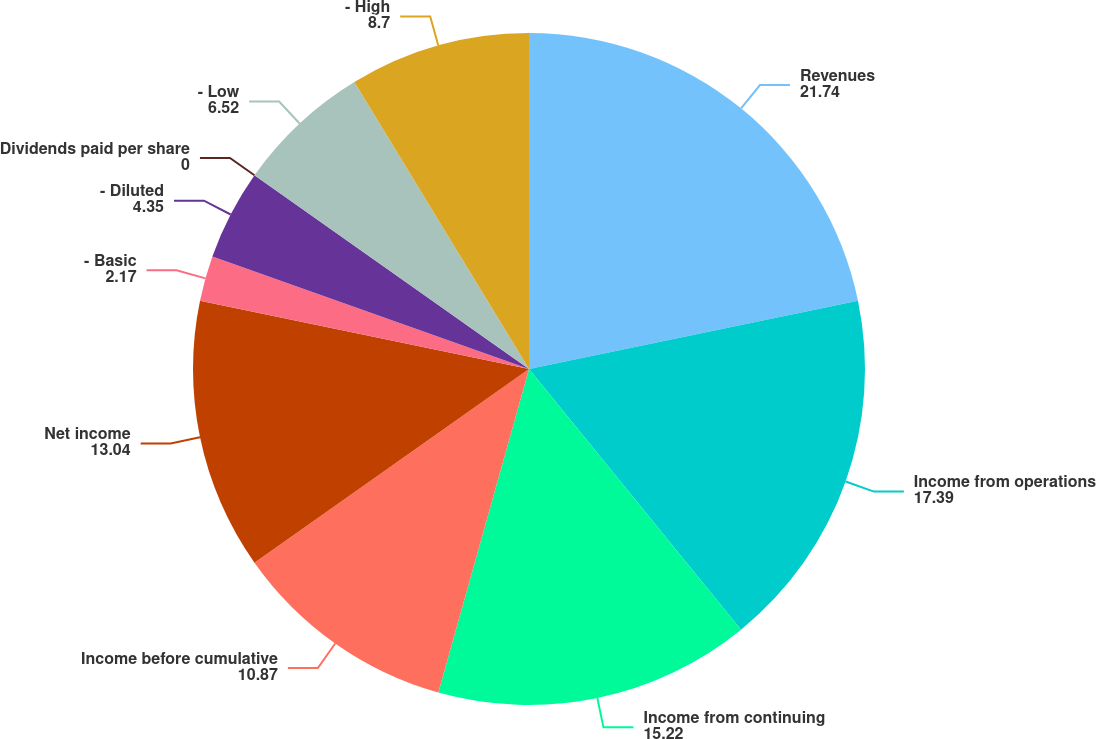Convert chart to OTSL. <chart><loc_0><loc_0><loc_500><loc_500><pie_chart><fcel>Revenues<fcel>Income from operations<fcel>Income from continuing<fcel>Income before cumulative<fcel>Net income<fcel>- Basic<fcel>- Diluted<fcel>Dividends paid per share<fcel>- Low<fcel>- High<nl><fcel>21.74%<fcel>17.39%<fcel>15.22%<fcel>10.87%<fcel>13.04%<fcel>2.17%<fcel>4.35%<fcel>0.0%<fcel>6.52%<fcel>8.7%<nl></chart> 